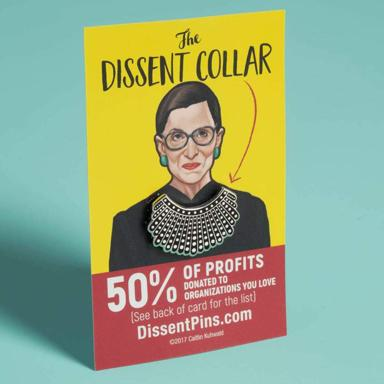What is the Dissent Collar, and what does it support? The Dissent Collar is not just a stylish accessory but has deep-rooted symbolism connected to Justice Ruth Bader Ginsburg, who famously wore this type of collar when announcing her dissenting opinions in the Supreme Court. It's become a powerful emblem of justice and women's rights. This particular product does more than carry her legacy; it actively contributes to it. As shown in the image, 50% of the profits from this collar are donated to charities chosen by its purchasers, making this collar both a statement of dissent and a tool for societal change. 